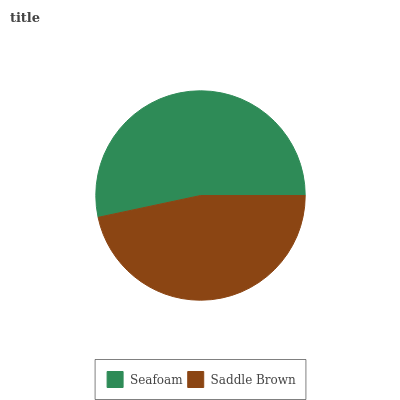Is Saddle Brown the minimum?
Answer yes or no. Yes. Is Seafoam the maximum?
Answer yes or no. Yes. Is Saddle Brown the maximum?
Answer yes or no. No. Is Seafoam greater than Saddle Brown?
Answer yes or no. Yes. Is Saddle Brown less than Seafoam?
Answer yes or no. Yes. Is Saddle Brown greater than Seafoam?
Answer yes or no. No. Is Seafoam less than Saddle Brown?
Answer yes or no. No. Is Seafoam the high median?
Answer yes or no. Yes. Is Saddle Brown the low median?
Answer yes or no. Yes. Is Saddle Brown the high median?
Answer yes or no. No. Is Seafoam the low median?
Answer yes or no. No. 